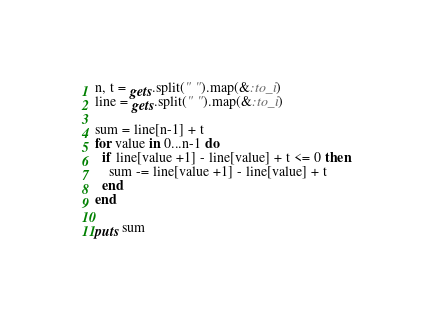<code> <loc_0><loc_0><loc_500><loc_500><_Ruby_>n, t = gets.split(" ").map(&:to_i)
line = gets.split(" ").map(&:to_i)

sum = line[n-1] + t
for value in 0...n-1 do
  if line[value +1] - line[value] + t <= 0 then
    sum -= line[value +1] - line[value] + t
  end
end

puts sum</code> 